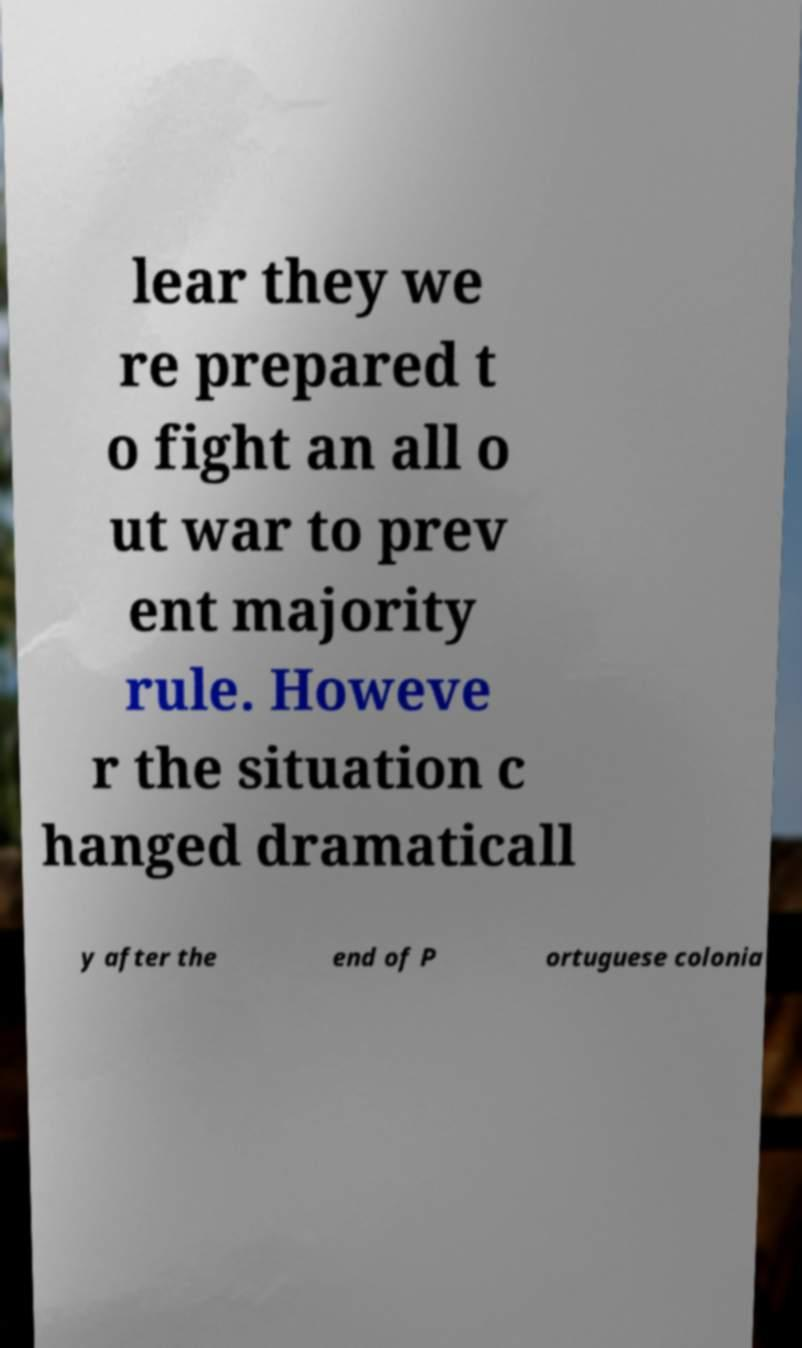For documentation purposes, I need the text within this image transcribed. Could you provide that? lear they we re prepared t o fight an all o ut war to prev ent majority rule. Howeve r the situation c hanged dramaticall y after the end of P ortuguese colonia 